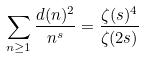Convert formula to latex. <formula><loc_0><loc_0><loc_500><loc_500>\sum _ { n \geq 1 } \frac { d ( n ) ^ { 2 } } { n ^ { s } } = \frac { \zeta ( s ) ^ { 4 } } { \zeta ( 2 s ) }</formula> 